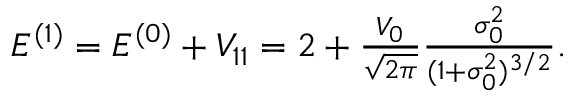<formula> <loc_0><loc_0><loc_500><loc_500>\begin{array} { r } { E ^ { ( 1 ) } = E ^ { ( 0 ) } + V _ { 1 1 } = 2 + \frac { V _ { 0 } } { \sqrt { 2 \pi } } \frac { \sigma _ { 0 } ^ { 2 } } { ( 1 + \sigma _ { 0 } ^ { 2 } ) ^ { 3 / 2 } } . } \end{array}</formula> 